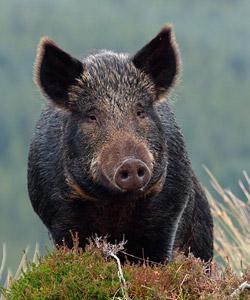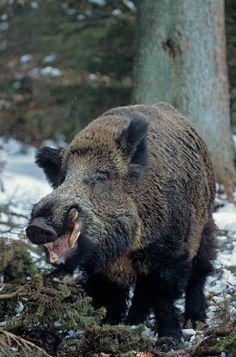The first image is the image on the left, the second image is the image on the right. Examine the images to the left and right. Is the description "In at least one image there is a black eared boar with there body facing right while it's snout is facing forward left." accurate? Answer yes or no. No. 